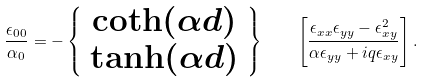<formula> <loc_0><loc_0><loc_500><loc_500>\frac { \epsilon _ { 0 0 } } { \alpha _ { 0 } } = - \left \{ \begin{array} { c } \coth ( \alpha d ) \\ \tanh ( \alpha d ) \end{array} \right \} \quad \left [ \frac { \epsilon _ { x x } \epsilon _ { y y } - \epsilon _ { x y } ^ { 2 } } { \alpha \epsilon _ { y y } + i q \epsilon _ { x y } } \right ] .</formula> 